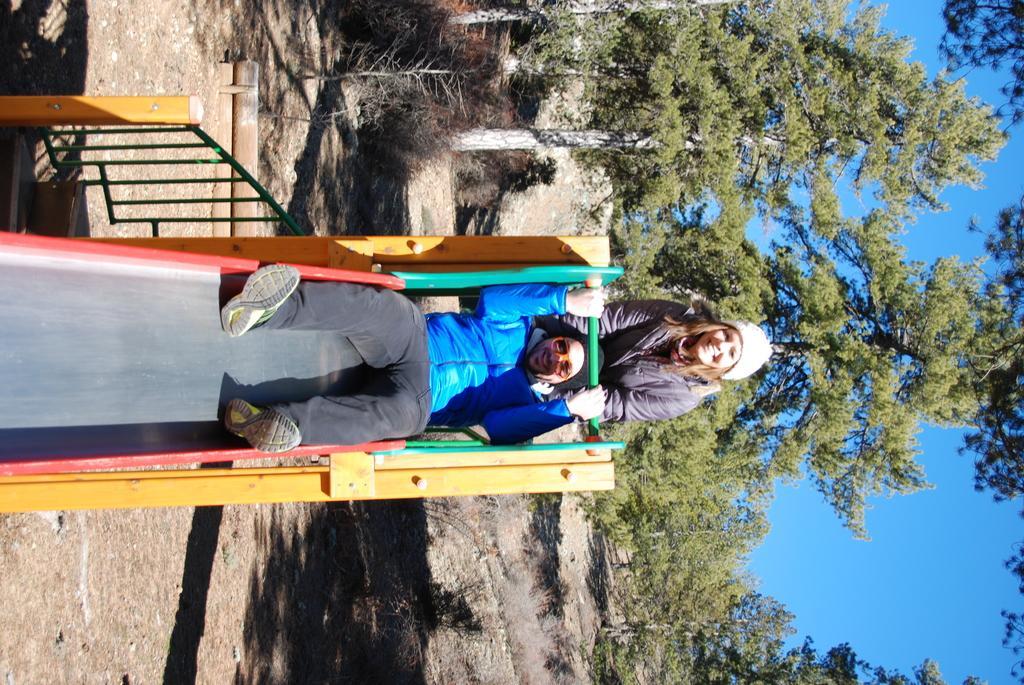How would you summarize this image in a sentence or two? This image is taken outdoors. At the bottom of the image there is a ground. On the right side of the image there is a sky. In the background there are many trees and plants. On the left side of the image there is a slide and a railing. In the middle of the image a woman is standing on the ground and a man is sitting on the slide. 